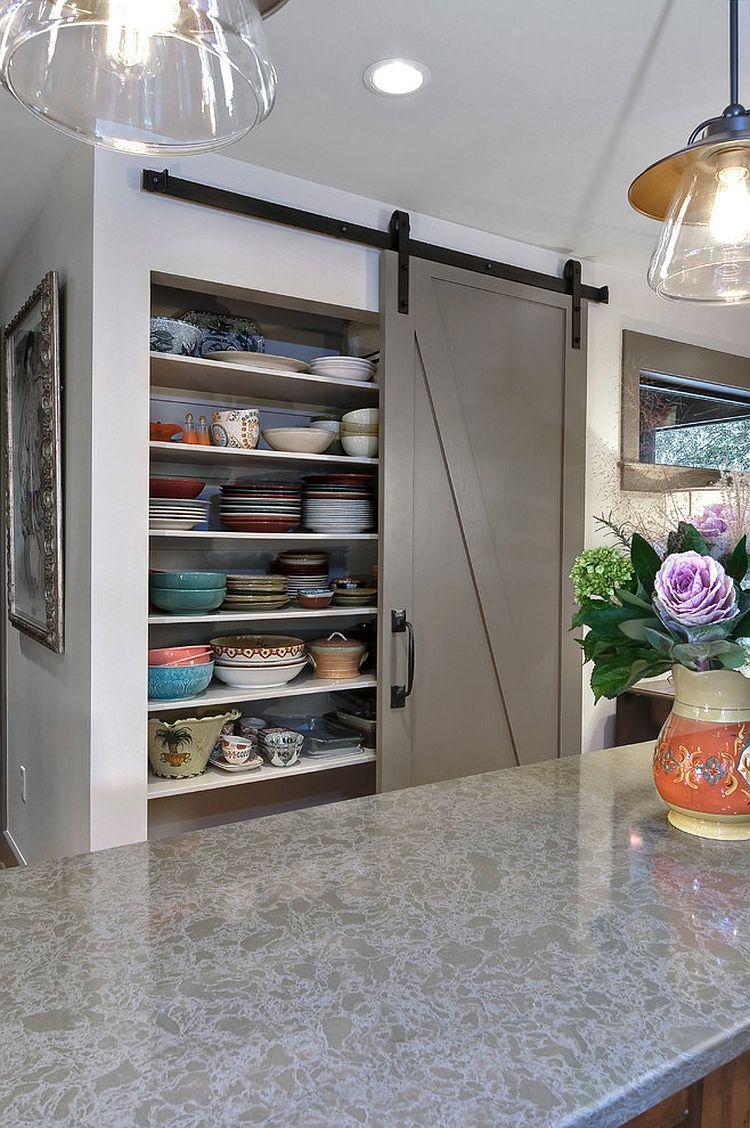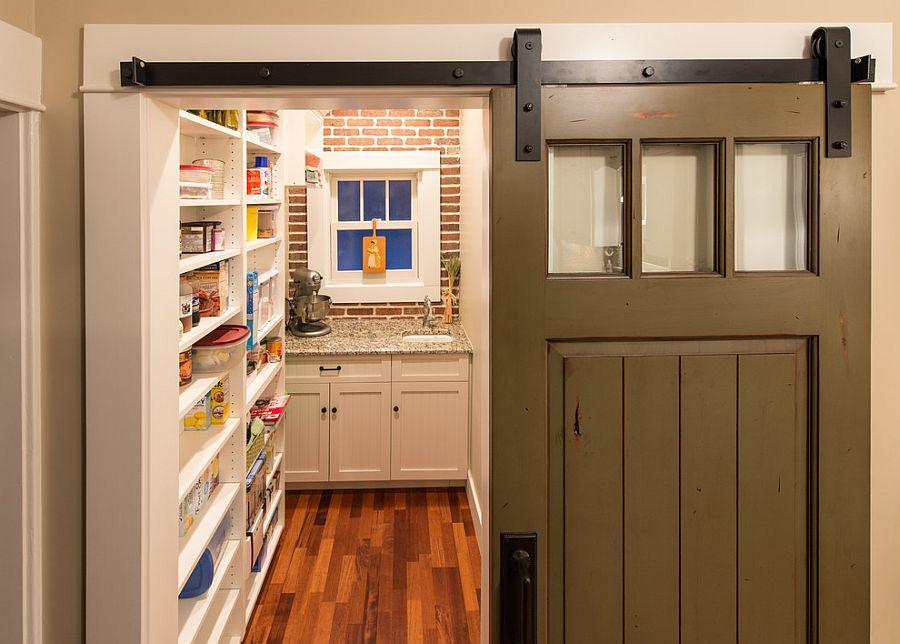The first image is the image on the left, the second image is the image on the right. Assess this claim about the two images: "One image shows white barn-style double doors that slide on an overhead black bar, and the doors are open revealing filled shelves.". Correct or not? Answer yes or no. No. The first image is the image on the left, the second image is the image on the right. For the images displayed, is the sentence "The left and right image contains the same number of hanging doors." factually correct? Answer yes or no. Yes. 